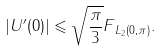Convert formula to latex. <formula><loc_0><loc_0><loc_500><loc_500>| U ^ { \prime } ( 0 ) | \leqslant \sqrt { \frac { \pi } { 3 } } \| F \| _ { L _ { 2 } ( 0 , \pi ) } .</formula> 